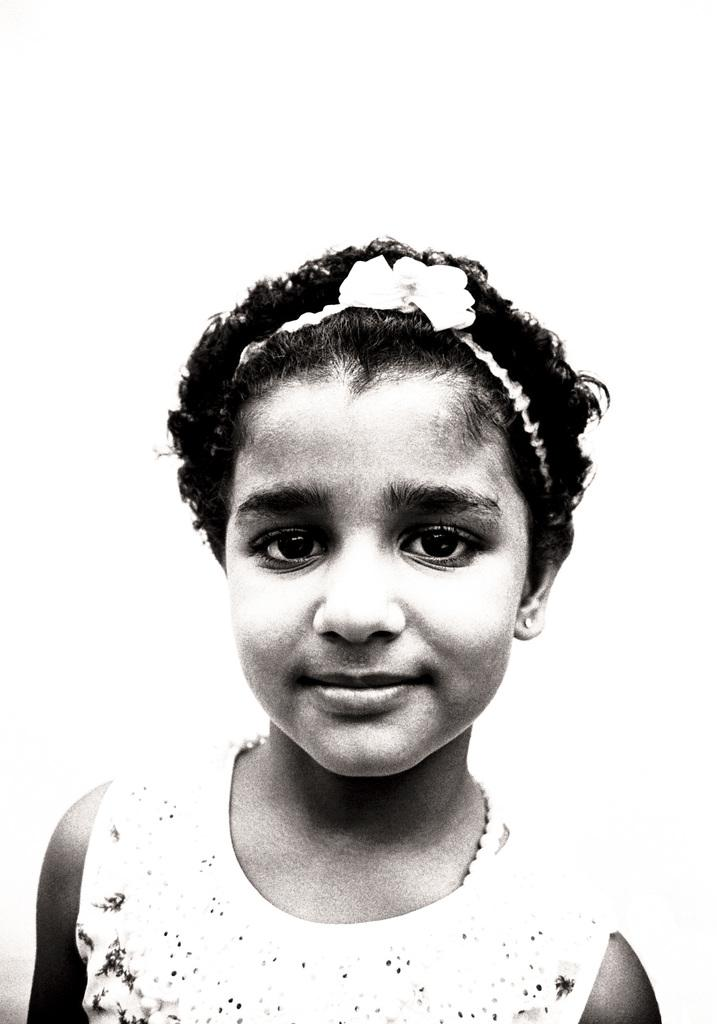Who or what is present in the image? There is a person in the image. What can be seen behind the person? The background of the image is white. What type of jelly is being exchanged between the person and the bear in the image? There is no bear or jelly present in the image; it only features a person with a white background. 